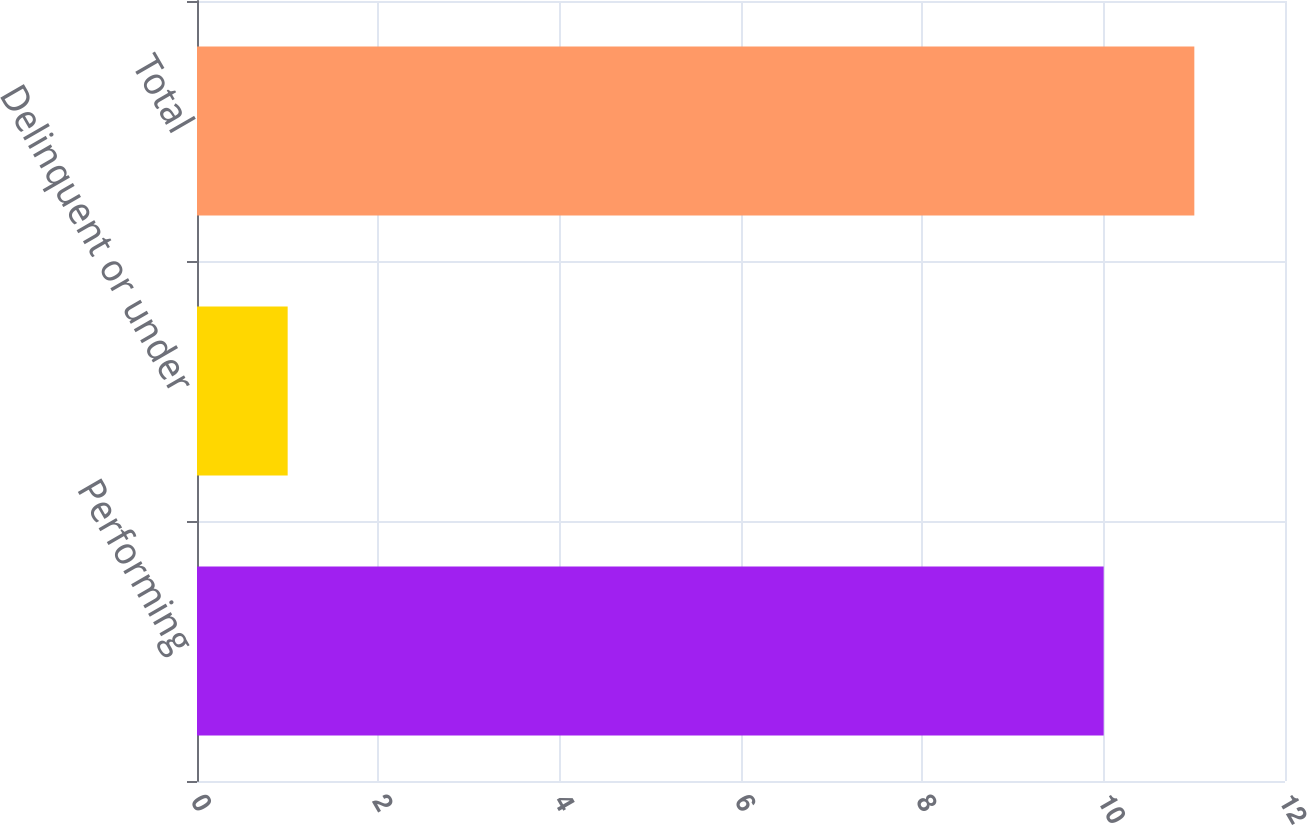Convert chart. <chart><loc_0><loc_0><loc_500><loc_500><bar_chart><fcel>Performing<fcel>Delinquent or under<fcel>Total<nl><fcel>10<fcel>1<fcel>11<nl></chart> 